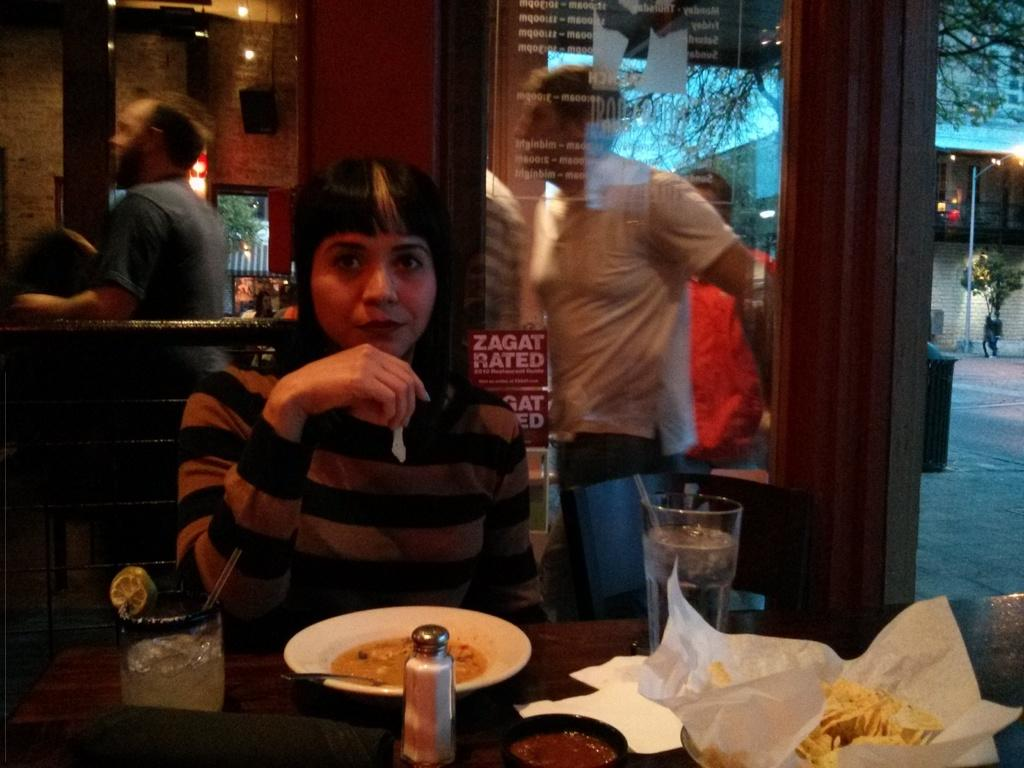Who is present in the image? There is a woman in the image. What is the woman doing in the image? The woman is sitting at a table. What can be seen on the table in the image? There is a glass of soda water, a drink glass, and a plate with food on the table. Can you describe the background of the image? There are people standing in the background of the image. What type of oven is visible in the image? There is no oven present in the image. How many legs does the woman have in the image? The image does not show the woman's legs, so it is impossible to determine the number of legs she has in the image. 